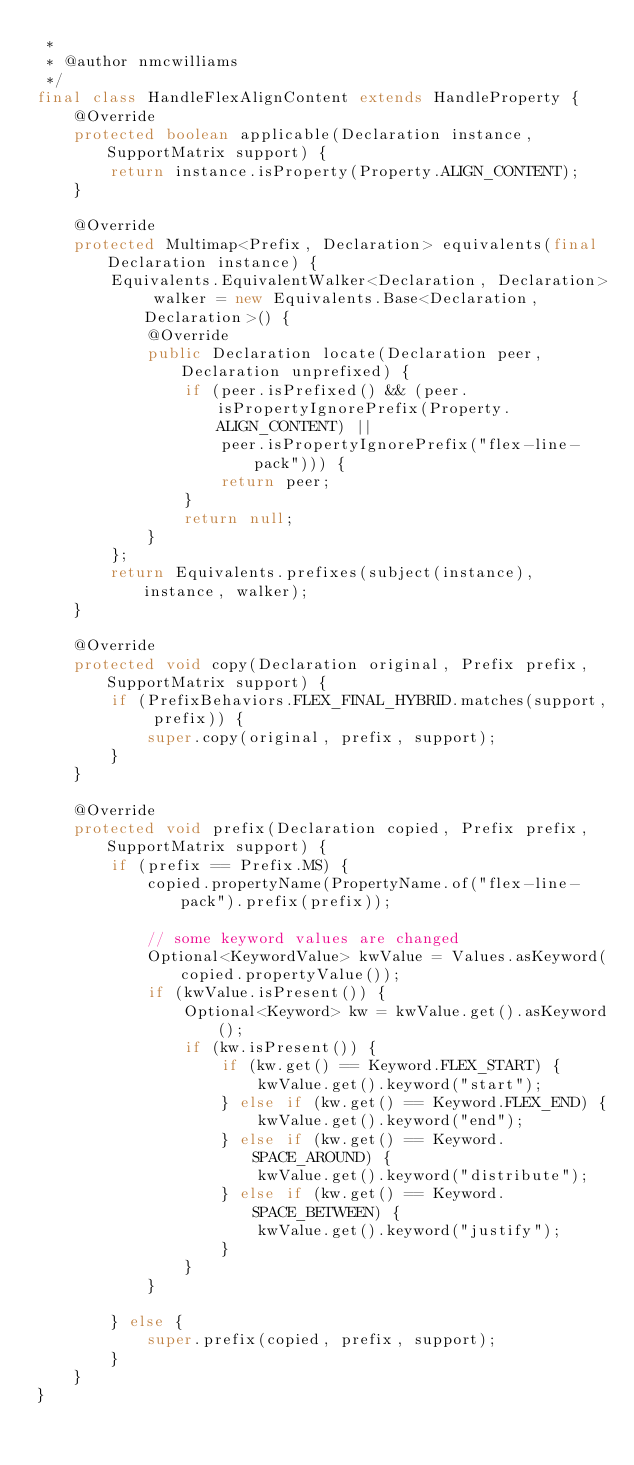<code> <loc_0><loc_0><loc_500><loc_500><_Java_> *
 * @author nmcwilliams
 */
final class HandleFlexAlignContent extends HandleProperty {
    @Override
    protected boolean applicable(Declaration instance, SupportMatrix support) {
        return instance.isProperty(Property.ALIGN_CONTENT);
    }

    @Override
    protected Multimap<Prefix, Declaration> equivalents(final Declaration instance) {
        Equivalents.EquivalentWalker<Declaration, Declaration> walker = new Equivalents.Base<Declaration, Declaration>() {
            @Override
            public Declaration locate(Declaration peer, Declaration unprefixed) {
                if (peer.isPrefixed() && (peer.isPropertyIgnorePrefix(Property.ALIGN_CONTENT) ||
                    peer.isPropertyIgnorePrefix("flex-line-pack"))) {
                    return peer;
                }
                return null;
            }
        };
        return Equivalents.prefixes(subject(instance), instance, walker);
    }

    @Override
    protected void copy(Declaration original, Prefix prefix, SupportMatrix support) {
        if (PrefixBehaviors.FLEX_FINAL_HYBRID.matches(support, prefix)) {
            super.copy(original, prefix, support);
        }
    }

    @Override
    protected void prefix(Declaration copied, Prefix prefix, SupportMatrix support) {
        if (prefix == Prefix.MS) {
            copied.propertyName(PropertyName.of("flex-line-pack").prefix(prefix));

            // some keyword values are changed
            Optional<KeywordValue> kwValue = Values.asKeyword(copied.propertyValue());
            if (kwValue.isPresent()) {
                Optional<Keyword> kw = kwValue.get().asKeyword();
                if (kw.isPresent()) {
                    if (kw.get() == Keyword.FLEX_START) {
                        kwValue.get().keyword("start");
                    } else if (kw.get() == Keyword.FLEX_END) {
                        kwValue.get().keyword("end");
                    } else if (kw.get() == Keyword.SPACE_AROUND) {
                        kwValue.get().keyword("distribute");
                    } else if (kw.get() == Keyword.SPACE_BETWEEN) {
                        kwValue.get().keyword("justify");
                    }
                }
            }

        } else {
            super.prefix(copied, prefix, support);
        }
    }
}
</code> 